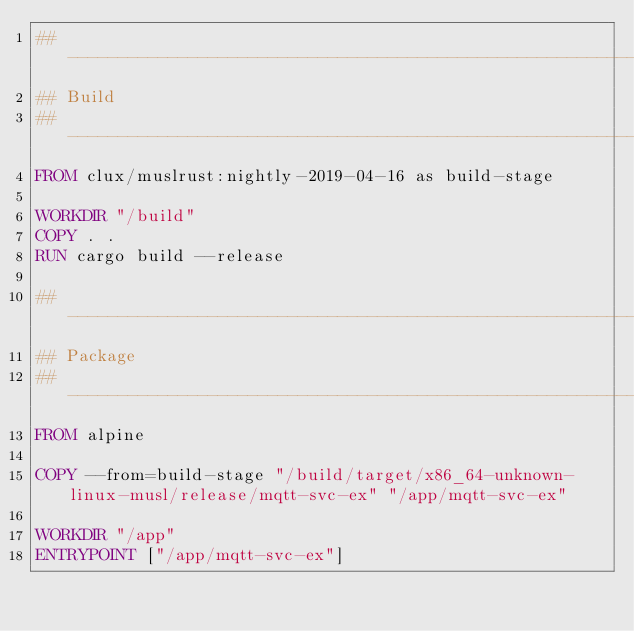Convert code to text. <code><loc_0><loc_0><loc_500><loc_500><_Dockerfile_>## -----------------------------------------------------------------------------
## Build
## -----------------------------------------------------------------------------
FROM clux/muslrust:nightly-2019-04-16 as build-stage

WORKDIR "/build"
COPY . .
RUN cargo build --release

## -----------------------------------------------------------------------------
## Package
## -----------------------------------------------------------------------------
FROM alpine

COPY --from=build-stage "/build/target/x86_64-unknown-linux-musl/release/mqtt-svc-ex" "/app/mqtt-svc-ex"

WORKDIR "/app"
ENTRYPOINT ["/app/mqtt-svc-ex"]
</code> 